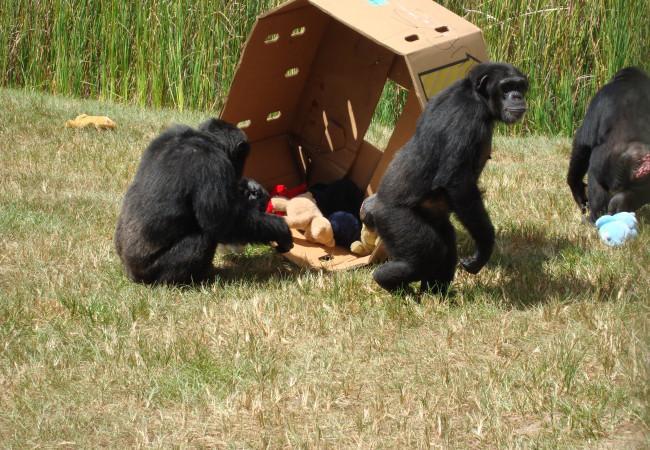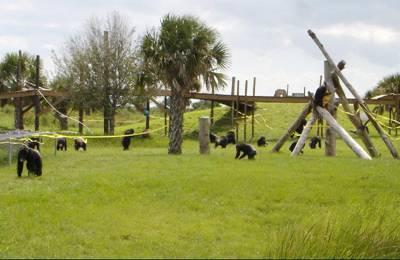The first image is the image on the left, the second image is the image on the right. Evaluate the accuracy of this statement regarding the images: "There are more primates in the image on the right.". Is it true? Answer yes or no. Yes. The first image is the image on the left, the second image is the image on the right. Considering the images on both sides, is "One image shows a group of chimps outdoors in front of a brown squarish structure, and the other image shows chimps near a tree and manmade structures." valid? Answer yes or no. Yes. 